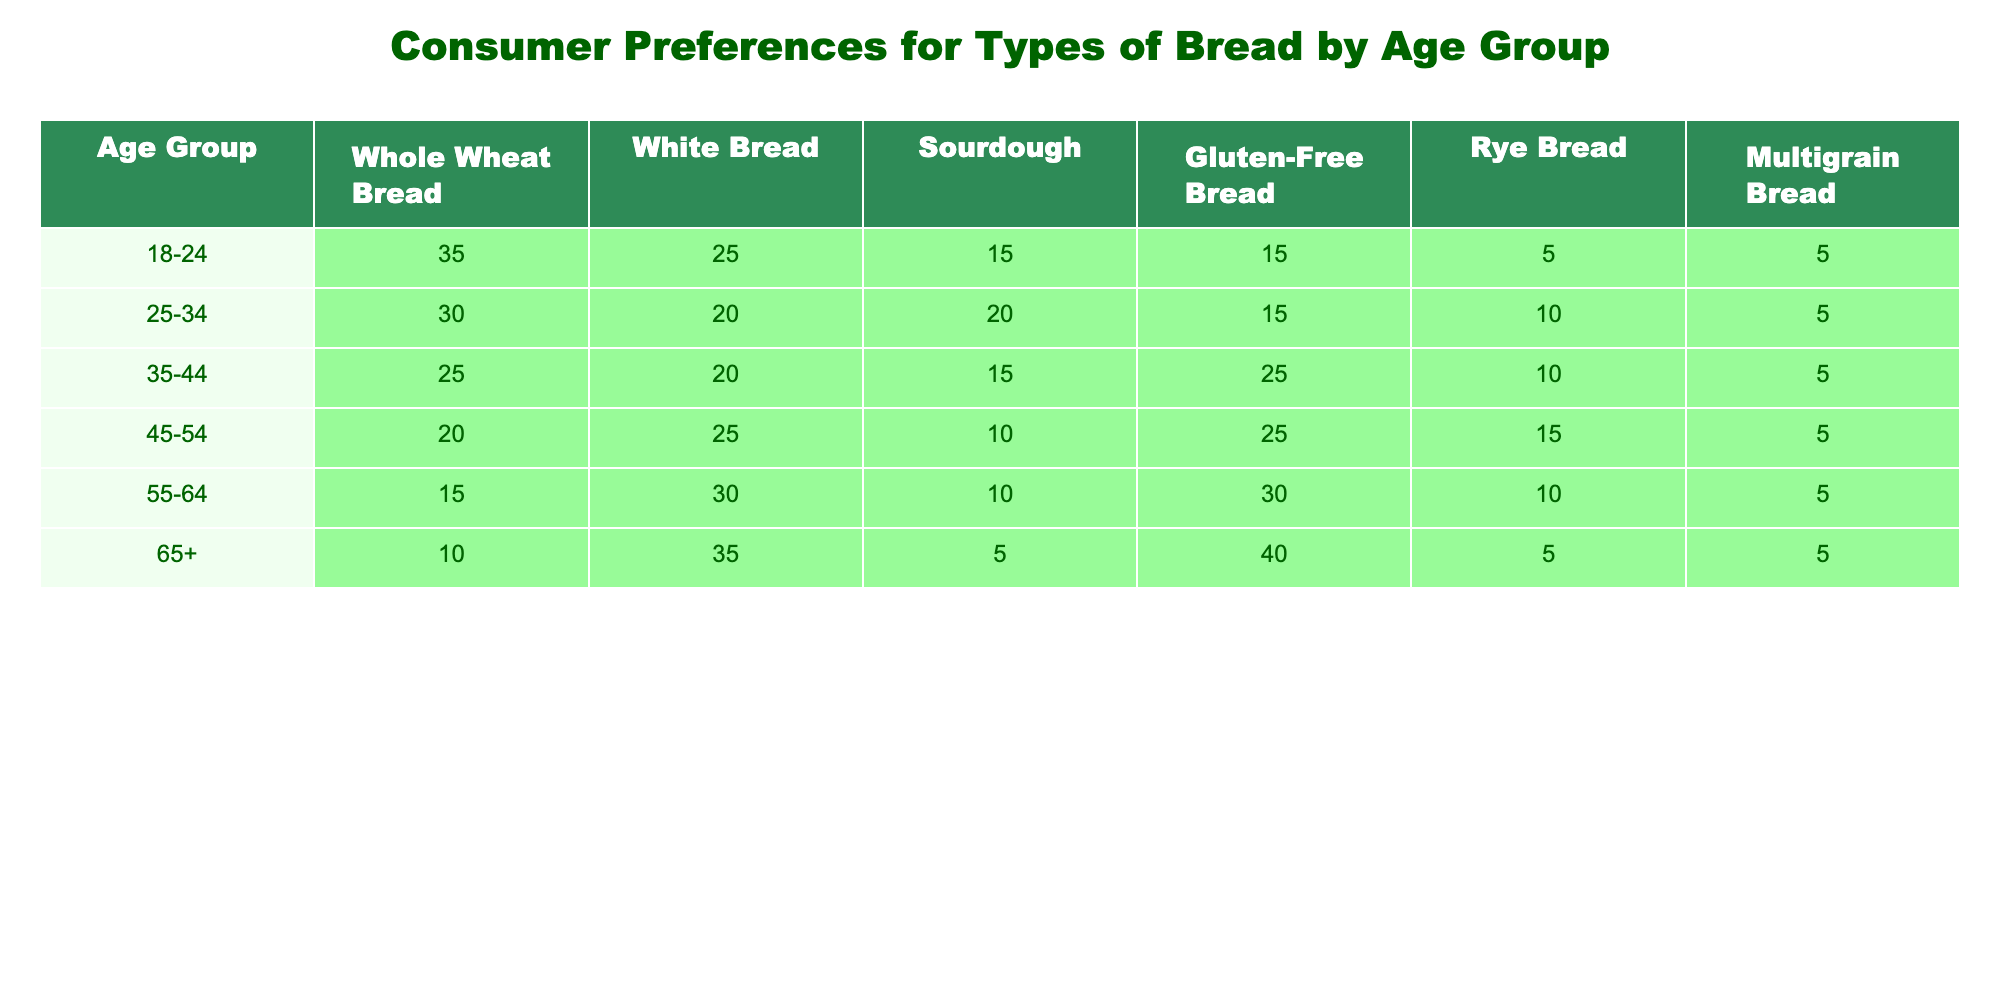What age group has the highest preference for white bread? Referring to the table, the age group 65+ has the highest preference for white bread with 35%.
Answer: 65+ Which type of bread is most preferred by the 35-44 age group? The 35-44 age group prefers gluten-free bread, with 25% preference, compared to others.
Answer: Gluten-Free Bread What is the total percentage of whole wheat bread preference across all age groups? Adding the values for whole wheat bread: 35 + 30 + 25 + 20 + 15 + 10 = 135%.
Answer: 135% Is there any age group that prefers rye bread over sourdough? Based on the table, no age group prefers rye bread over sourdough since rye has lower percentages across all age groups compared to sourdough.
Answer: No Which age group shows the smallest interest in multigrain bread? The 18-24 age group shows the smallest interest in multigrain bread with only 5%.
Answer: 18-24 What is the average preference for sourdough bread among all age groups? The average preference for sourdough bread is calculated as follows: (15 + 20 + 15 + 10 + 10 + 5) = 75; then 75 divided by 6 = 12.5%.
Answer: 12.5% Does the preference for gluten-free bread increase with age? Yes, the table shows an increasing trend in gluten-free bread preferences as the age group increases, particularly peaking at 40% in the 65+ category.
Answer: Yes What is the difference in the percentage of white bread preference between the age groups 25-34 and 45-54? The preference for white bread for the 25-34 group is 20% and for 45-54 group is 25%, thus the difference is 25 - 20 = 5%.
Answer: 5% Which type of bread has the least preference from the 55-64 age group? Among the 55-64 age group, multigrain bread has the least preference at just 5%.
Answer: Multigrain Bread If the 18-24 age group decided to completely switch from whole wheat to sourdough, what would be their new percentage for sourdough? The 18-24 age group currently prefers sourdough at 15%. If they switch entirely from whole wheat, its preference of 35% would be added to sourdough, making their new total for sourdough: 15 + 35 = 50%.
Answer: 50% 